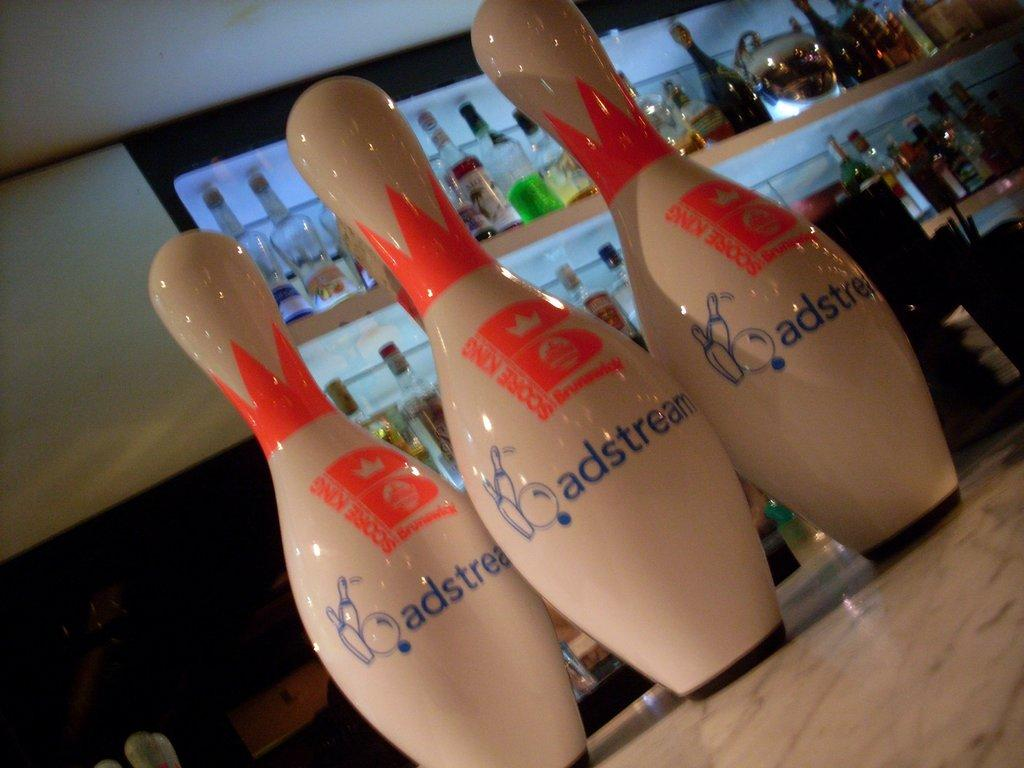<image>
Offer a succinct explanation of the picture presented. White bowling pins have blue lettering stating, adstream." 